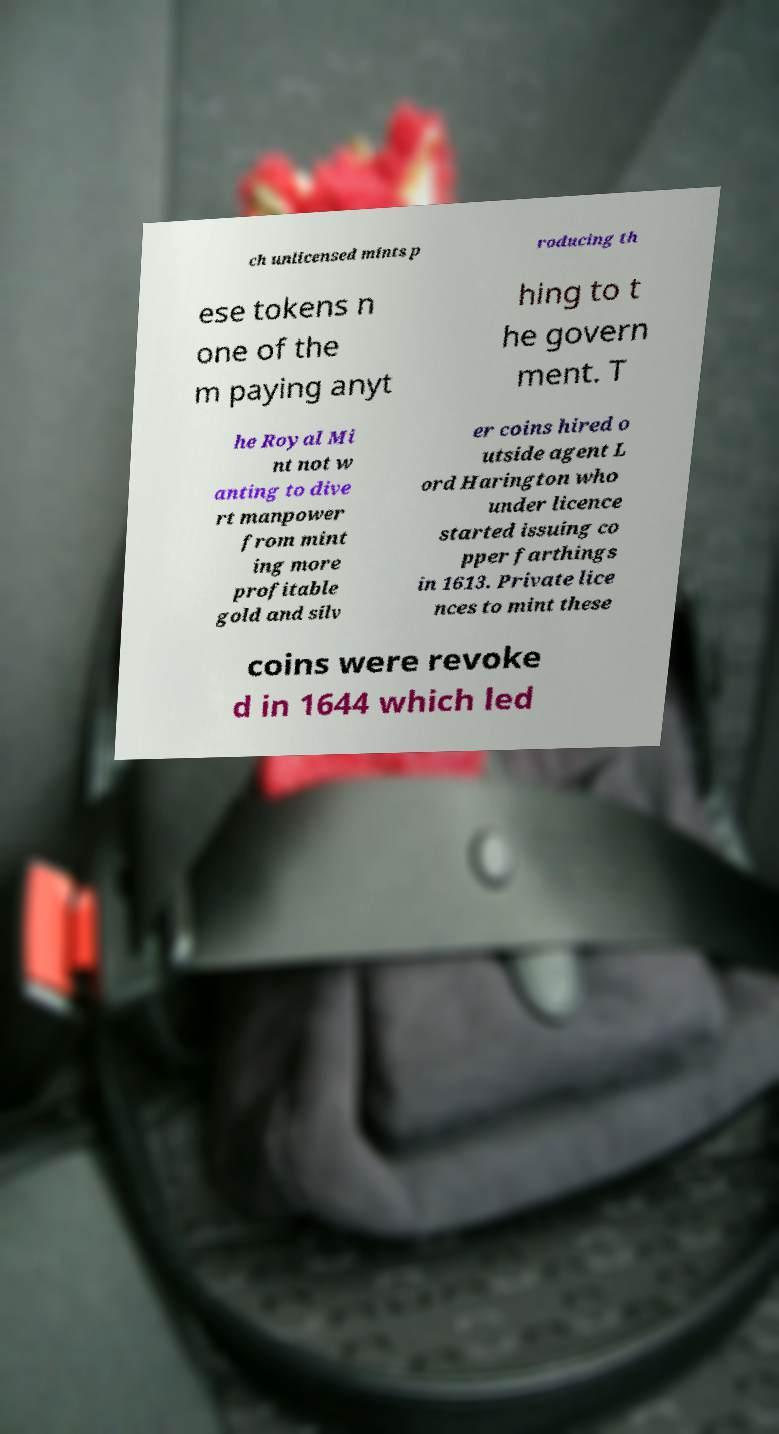There's text embedded in this image that I need extracted. Can you transcribe it verbatim? ch unlicensed mints p roducing th ese tokens n one of the m paying anyt hing to t he govern ment. T he Royal Mi nt not w anting to dive rt manpower from mint ing more profitable gold and silv er coins hired o utside agent L ord Harington who under licence started issuing co pper farthings in 1613. Private lice nces to mint these coins were revoke d in 1644 which led 